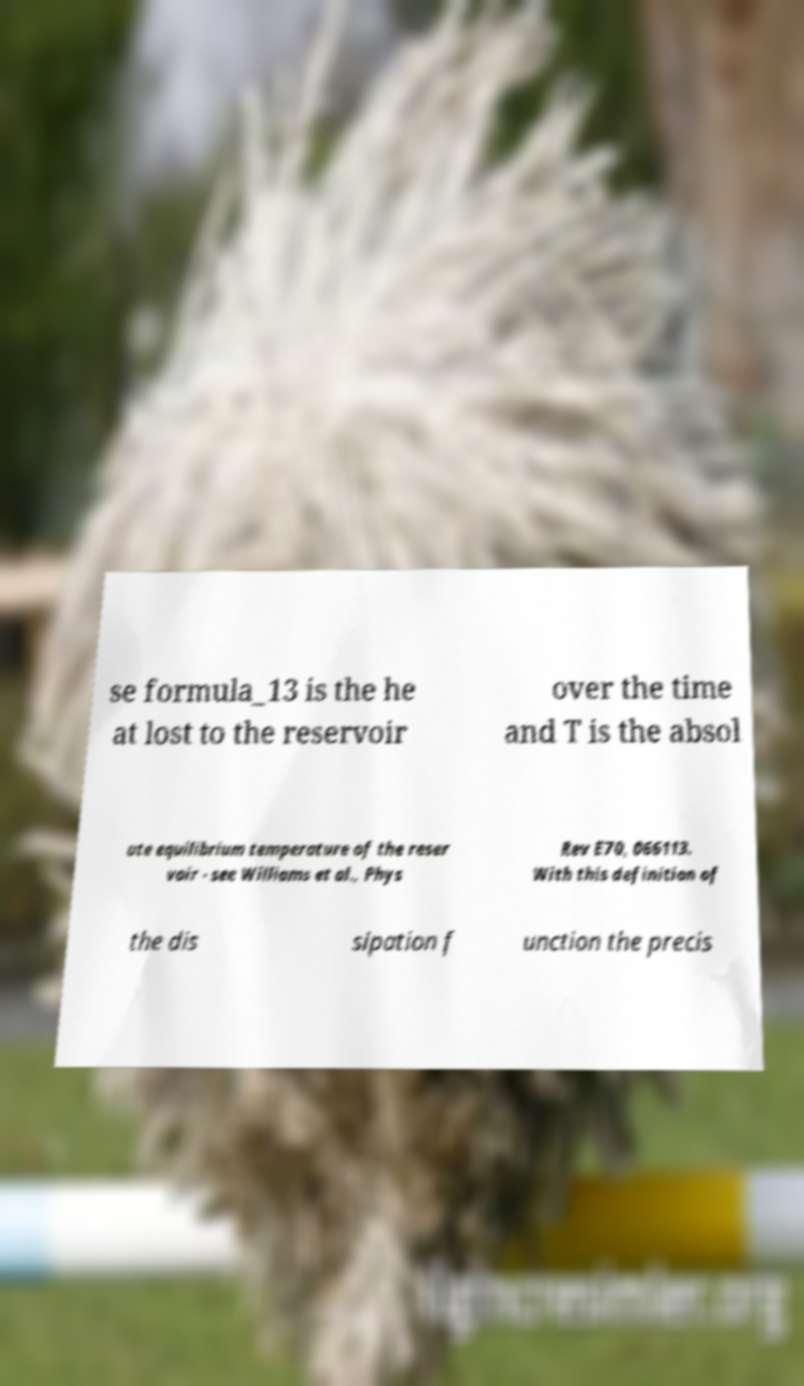Can you read and provide the text displayed in the image?This photo seems to have some interesting text. Can you extract and type it out for me? se formula_13 is the he at lost to the reservoir over the time and T is the absol ute equilibrium temperature of the reser voir - see Williams et al., Phys Rev E70, 066113. With this definition of the dis sipation f unction the precis 